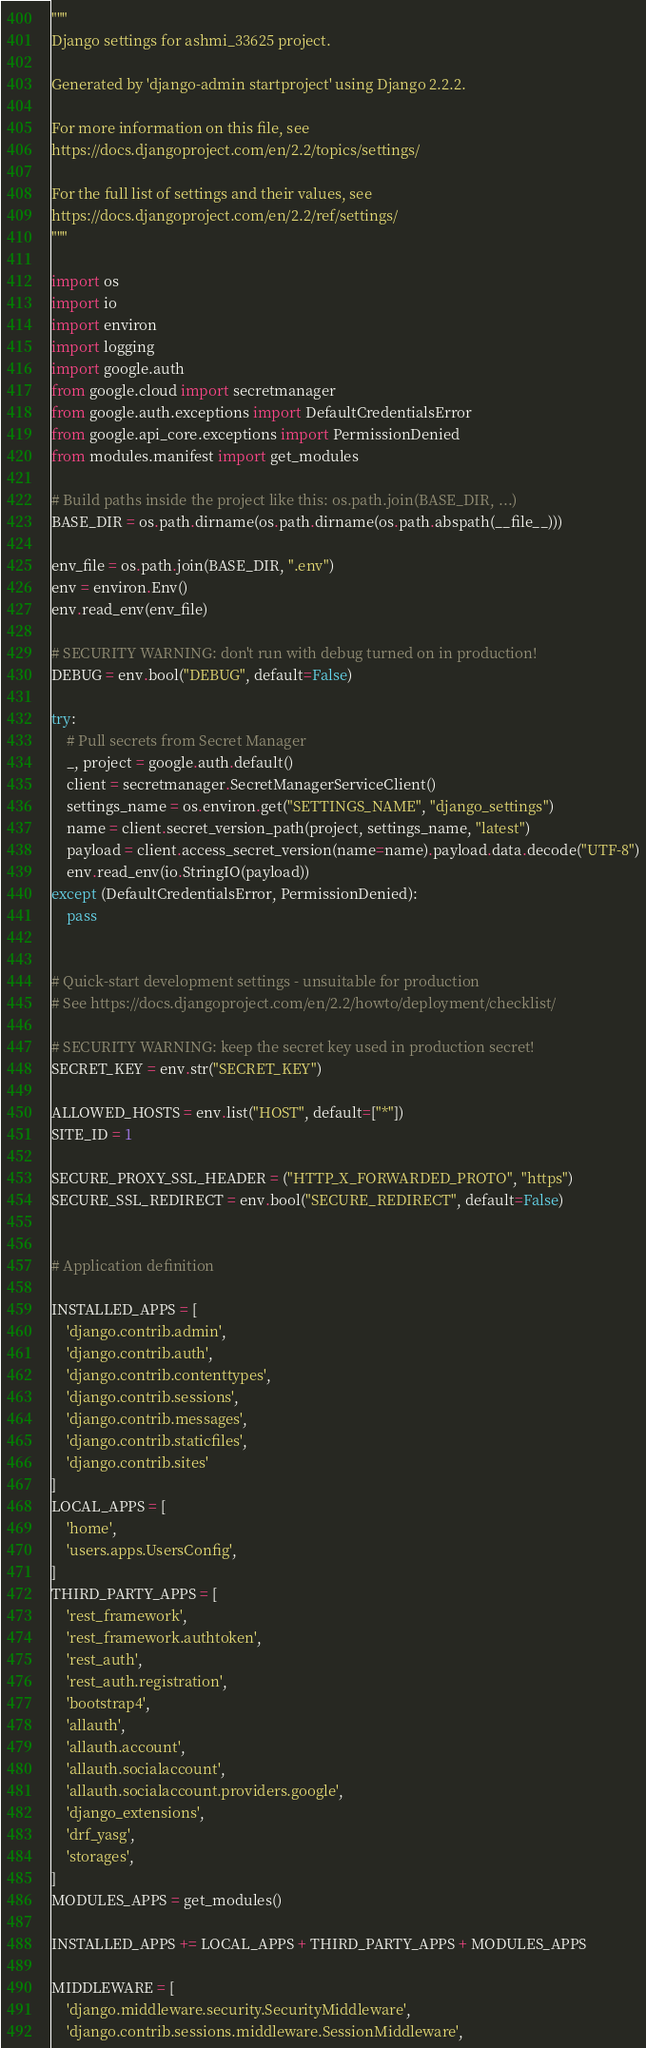<code> <loc_0><loc_0><loc_500><loc_500><_Python_>"""
Django settings for ashmi_33625 project.

Generated by 'django-admin startproject' using Django 2.2.2.

For more information on this file, see
https://docs.djangoproject.com/en/2.2/topics/settings/

For the full list of settings and their values, see
https://docs.djangoproject.com/en/2.2/ref/settings/
"""

import os
import io
import environ
import logging
import google.auth
from google.cloud import secretmanager
from google.auth.exceptions import DefaultCredentialsError
from google.api_core.exceptions import PermissionDenied
from modules.manifest import get_modules

# Build paths inside the project like this: os.path.join(BASE_DIR, ...)
BASE_DIR = os.path.dirname(os.path.dirname(os.path.abspath(__file__)))

env_file = os.path.join(BASE_DIR, ".env")
env = environ.Env()
env.read_env(env_file)

# SECURITY WARNING: don't run with debug turned on in production!
DEBUG = env.bool("DEBUG", default=False)

try:
    # Pull secrets from Secret Manager
    _, project = google.auth.default()
    client = secretmanager.SecretManagerServiceClient()
    settings_name = os.environ.get("SETTINGS_NAME", "django_settings")
    name = client.secret_version_path(project, settings_name, "latest")
    payload = client.access_secret_version(name=name).payload.data.decode("UTF-8")
    env.read_env(io.StringIO(payload))
except (DefaultCredentialsError, PermissionDenied):
    pass


# Quick-start development settings - unsuitable for production
# See https://docs.djangoproject.com/en/2.2/howto/deployment/checklist/

# SECURITY WARNING: keep the secret key used in production secret!
SECRET_KEY = env.str("SECRET_KEY")

ALLOWED_HOSTS = env.list("HOST", default=["*"])
SITE_ID = 1

SECURE_PROXY_SSL_HEADER = ("HTTP_X_FORWARDED_PROTO", "https")
SECURE_SSL_REDIRECT = env.bool("SECURE_REDIRECT", default=False)


# Application definition

INSTALLED_APPS = [
    'django.contrib.admin',
    'django.contrib.auth',
    'django.contrib.contenttypes',
    'django.contrib.sessions',
    'django.contrib.messages',
    'django.contrib.staticfiles',
    'django.contrib.sites'
]
LOCAL_APPS = [
    'home',
    'users.apps.UsersConfig',
]
THIRD_PARTY_APPS = [
    'rest_framework',
    'rest_framework.authtoken',
    'rest_auth',
    'rest_auth.registration',
    'bootstrap4',
    'allauth',
    'allauth.account',
    'allauth.socialaccount',
    'allauth.socialaccount.providers.google',
    'django_extensions',
    'drf_yasg',
    'storages',
]
MODULES_APPS = get_modules()

INSTALLED_APPS += LOCAL_APPS + THIRD_PARTY_APPS + MODULES_APPS

MIDDLEWARE = [
    'django.middleware.security.SecurityMiddleware',
    'django.contrib.sessions.middleware.SessionMiddleware',</code> 